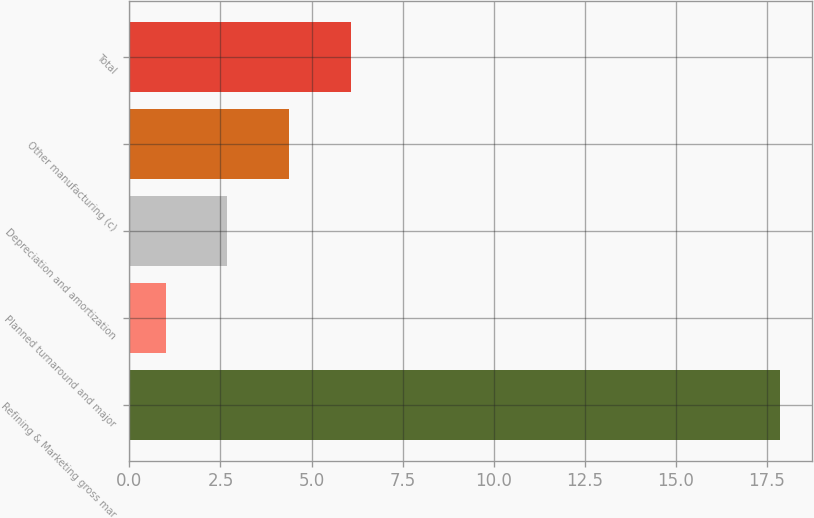Convert chart. <chart><loc_0><loc_0><loc_500><loc_500><bar_chart><fcel>Refining & Marketing gross mar<fcel>Planned turnaround and major<fcel>Depreciation and amortization<fcel>Other manufacturing (c)<fcel>Total<nl><fcel>17.85<fcel>1<fcel>2.69<fcel>4.38<fcel>6.07<nl></chart> 